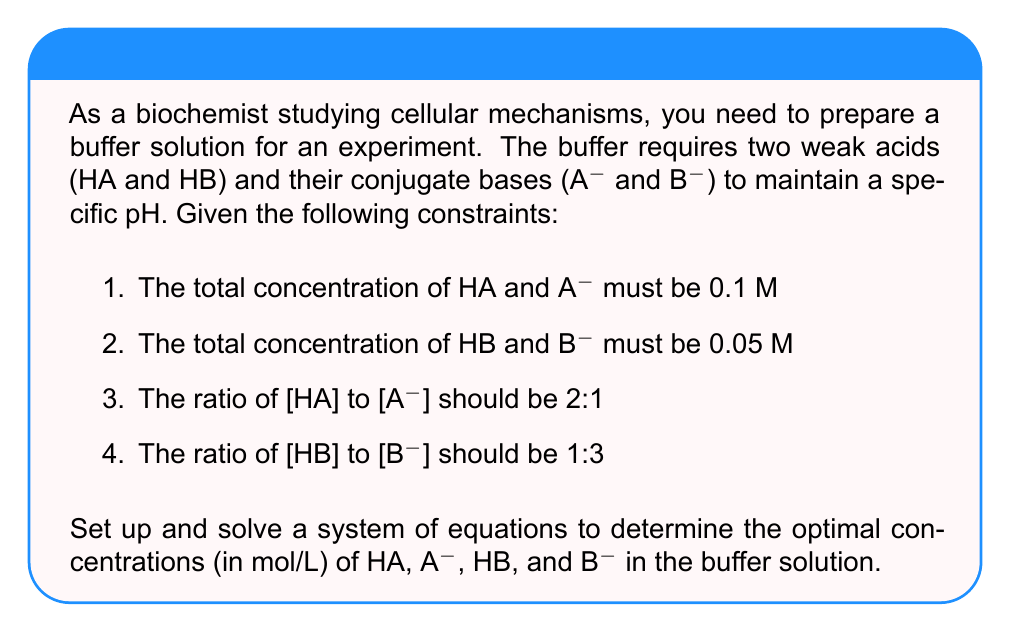Give your solution to this math problem. Let's approach this step-by-step:

1) Define variables:
   Let $x$ = [HA], $y$ = [A-], $z$ = [HB], and $w$ = [B-]

2) Set up equations based on the given constraints:

   a) Total concentration of HA and A-:
      $$x + y = 0.1$$

   b) Total concentration of HB and B-:
      $$z + w = 0.05$$

   c) Ratio of [HA] to [A-]:
      $$\frac{x}{y} = 2:1 \Rightarrow x = 2y$$

   d) Ratio of [HB] to [B-]:
      $$\frac{z}{w} = 1:3 \Rightarrow z = \frac{1}{3}w$$

3) Substitute equations (c) and (d) into (a) and (b):

   From (a): $2y + y = 0.1 \Rightarrow 3y = 0.1 \Rightarrow y = \frac{0.1}{3}$

   From (b): $\frac{1}{3}w + w = 0.05 \Rightarrow \frac{4}{3}w = 0.05 \Rightarrow w = \frac{0.05 \cdot 3}{4}$

4) Calculate the values:

   $y = \frac{0.1}{3} \approx 0.0333$ M
   $x = 2y = 2 \cdot \frac{0.1}{3} \approx 0.0667$ M

   $w = \frac{0.05 \cdot 3}{4} = 0.0375$ M
   $z = \frac{1}{3}w = \frac{1}{3} \cdot \frac{0.05 \cdot 3}{4} = 0.0125$ M

5) Verify the results:
   - $x + y = 0.0667 + 0.0333 = 0.1$ M (constraint 1 satisfied)
   - $z + w = 0.0125 + 0.0375 = 0.05$ M (constraint 2 satisfied)
   - $\frac{x}{y} = \frac{0.0667}{0.0333} = 2:1$ (constraint 3 satisfied)
   - $\frac{z}{w} = \frac{0.0125}{0.0375} = 1:3$ (constraint 4 satisfied)
Answer: The optimal concentrations are:
[HA] = 0.0667 M
[A-] = 0.0333 M
[HB] = 0.0125 M
[B-] = 0.0375 M 